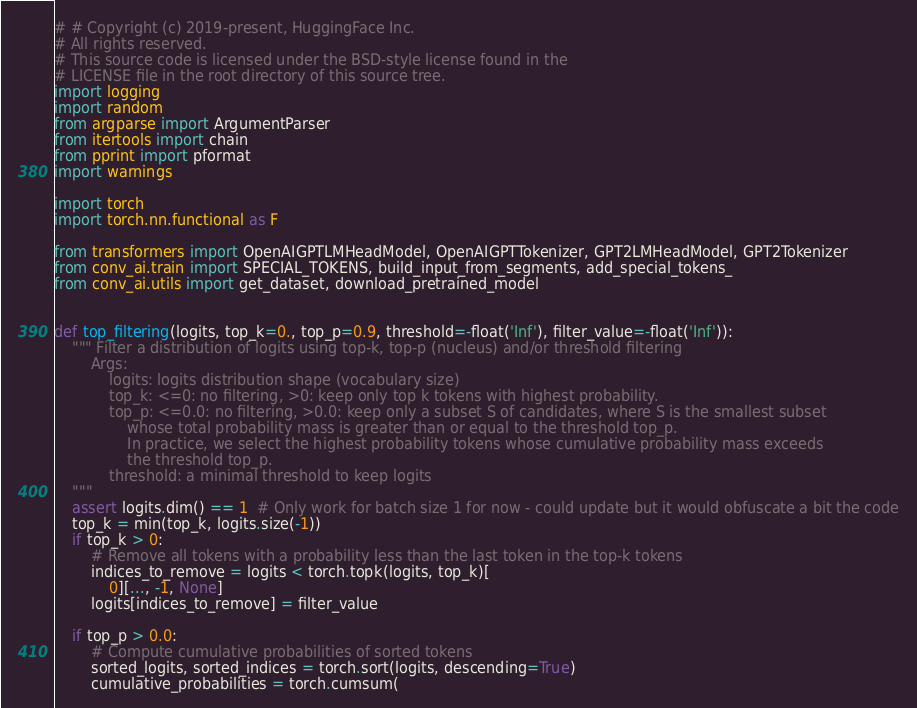<code> <loc_0><loc_0><loc_500><loc_500><_Python_># # Copyright (c) 2019-present, HuggingFace Inc.
# All rights reserved.
# This source code is licensed under the BSD-style license found in the
# LICENSE file in the root directory of this source tree.
import logging
import random
from argparse import ArgumentParser
from itertools import chain
from pprint import pformat
import warnings

import torch
import torch.nn.functional as F

from transformers import OpenAIGPTLMHeadModel, OpenAIGPTTokenizer, GPT2LMHeadModel, GPT2Tokenizer
from conv_ai.train import SPECIAL_TOKENS, build_input_from_segments, add_special_tokens_
from conv_ai.utils import get_dataset, download_pretrained_model


def top_filtering(logits, top_k=0., top_p=0.9, threshold=-float('Inf'), filter_value=-float('Inf')):
    """ Filter a distribution of logits using top-k, top-p (nucleus) and/or threshold filtering
        Args:
            logits: logits distribution shape (vocabulary size)
            top_k: <=0: no filtering, >0: keep only top k tokens with highest probability.
            top_p: <=0.0: no filtering, >0.0: keep only a subset S of candidates, where S is the smallest subset
                whose total probability mass is greater than or equal to the threshold top_p.
                In practice, we select the highest probability tokens whose cumulative probability mass exceeds
                the threshold top_p.
            threshold: a minimal threshold to keep logits
    """
    assert logits.dim() == 1  # Only work for batch size 1 for now - could update but it would obfuscate a bit the code
    top_k = min(top_k, logits.size(-1))
    if top_k > 0:
        # Remove all tokens with a probability less than the last token in the top-k tokens
        indices_to_remove = logits < torch.topk(logits, top_k)[
            0][..., -1, None]
        logits[indices_to_remove] = filter_value

    if top_p > 0.0:
        # Compute cumulative probabilities of sorted tokens
        sorted_logits, sorted_indices = torch.sort(logits, descending=True)
        cumulative_probabilities = torch.cumsum(</code> 